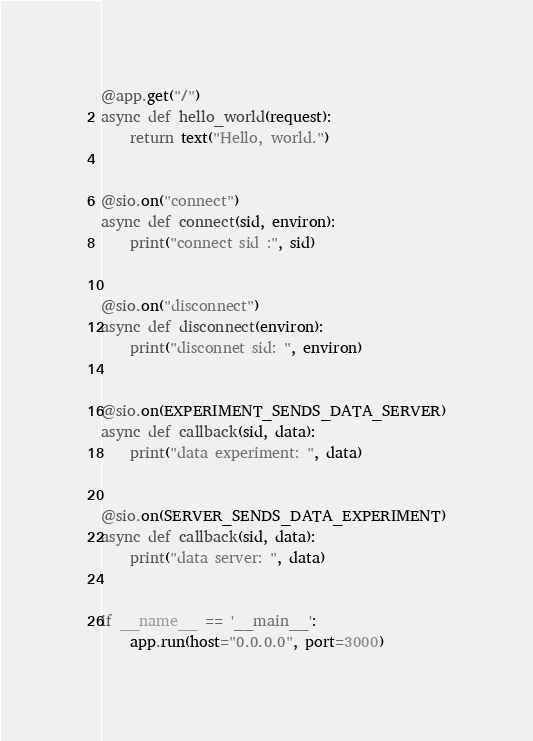Convert code to text. <code><loc_0><loc_0><loc_500><loc_500><_Python_>

@app.get("/")
async def hello_world(request):
    return text("Hello, world.")


@sio.on("connect")
async def connect(sid, environ):
    print("connect sid :", sid)


@sio.on("disconnect")
async def disconnect(environ):
    print("disconnet sid: ", environ)


@sio.on(EXPERIMENT_SENDS_DATA_SERVER)
async def callback(sid, data):
    print("data experiment: ", data)


@sio.on(SERVER_SENDS_DATA_EXPERIMENT)
async def callback(sid, data):
    print("data server: ", data)


if __name__ == '__main__':
    app.run(host="0.0.0.0", port=3000)</code> 